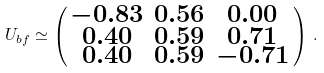Convert formula to latex. <formula><loc_0><loc_0><loc_500><loc_500>U _ { b f } \simeq \left ( \begin{smallmatrix} - 0 . 8 3 & 0 . 5 6 & 0 . 0 0 \\ 0 . 4 0 & 0 . 5 9 & 0 . 7 1 \\ 0 . 4 0 & 0 . 5 9 & - 0 . 7 1 \end{smallmatrix} \right ) \, .</formula> 